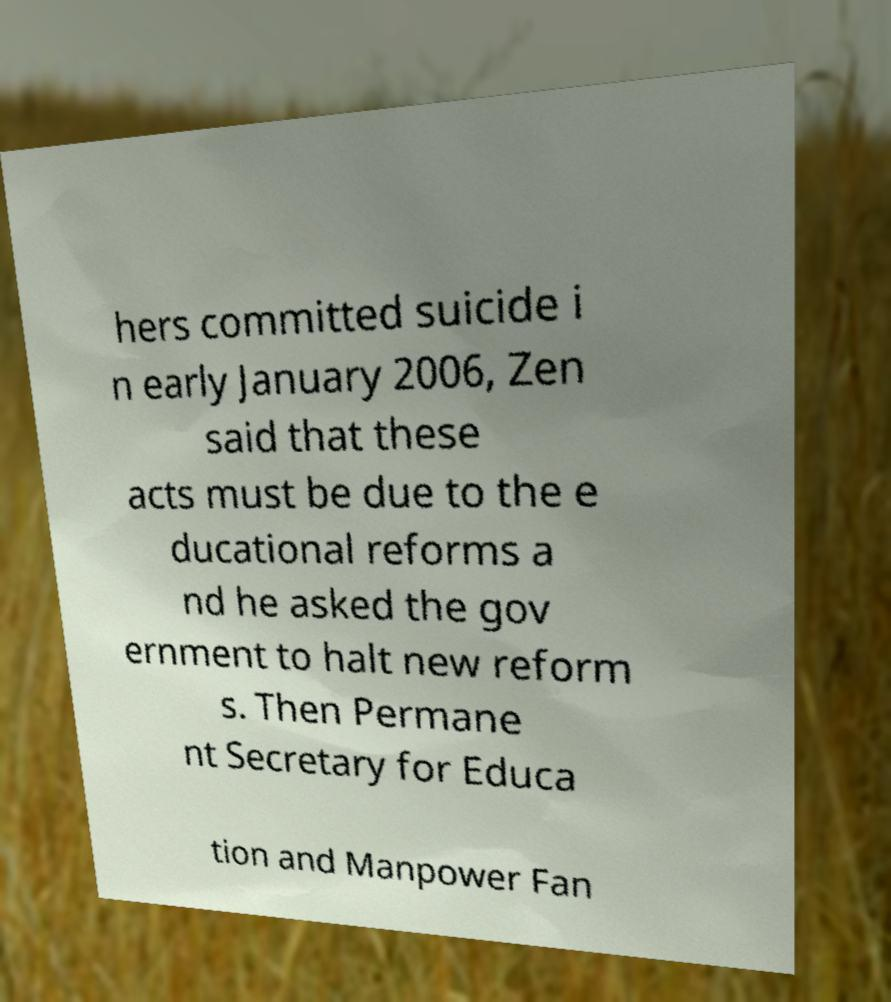Could you assist in decoding the text presented in this image and type it out clearly? hers committed suicide i n early January 2006, Zen said that these acts must be due to the e ducational reforms a nd he asked the gov ernment to halt new reform s. Then Permane nt Secretary for Educa tion and Manpower Fan 